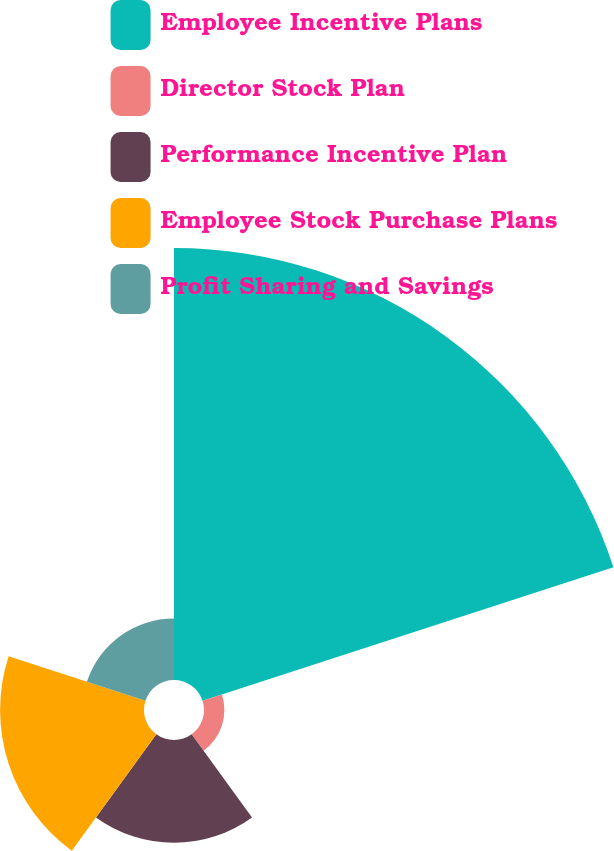<chart> <loc_0><loc_0><loc_500><loc_500><pie_chart><fcel>Employee Incentive Plans<fcel>Director Stock Plan<fcel>Performance Incentive Plan<fcel>Employee Stock Purchase Plans<fcel>Profit Sharing and Savings<nl><fcel>56.8%<fcel>2.68%<fcel>13.51%<fcel>18.92%<fcel>8.09%<nl></chart> 